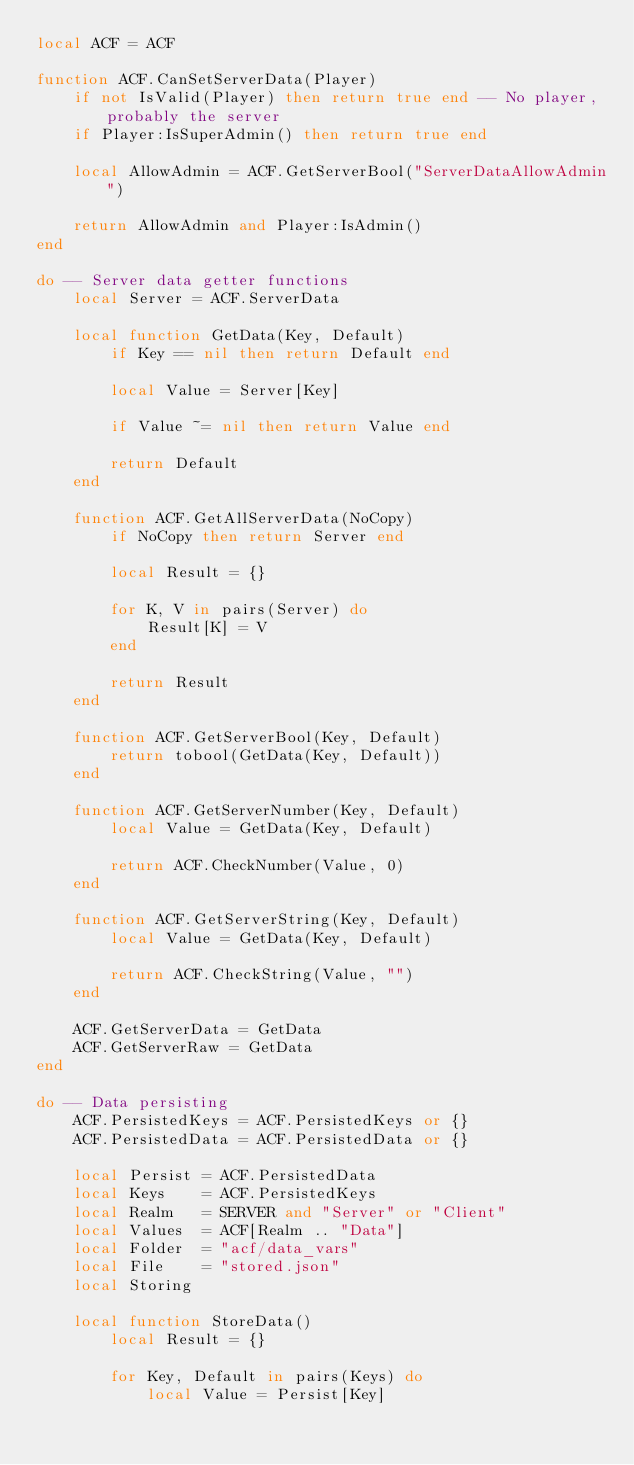Convert code to text. <code><loc_0><loc_0><loc_500><loc_500><_Lua_>local ACF = ACF

function ACF.CanSetServerData(Player)
	if not IsValid(Player) then return true end -- No player, probably the server
	if Player:IsSuperAdmin() then return true end

	local AllowAdmin = ACF.GetServerBool("ServerDataAllowAdmin")

	return AllowAdmin and Player:IsAdmin()
end

do -- Server data getter functions
	local Server = ACF.ServerData

	local function GetData(Key, Default)
		if Key == nil then return Default end

		local Value = Server[Key]

		if Value ~= nil then return Value end

		return Default
	end

	function ACF.GetAllServerData(NoCopy)
		if NoCopy then return Server end

		local Result = {}

		for K, V in pairs(Server) do
			Result[K] = V
		end

		return Result
	end

	function ACF.GetServerBool(Key, Default)
		return tobool(GetData(Key, Default))
	end

	function ACF.GetServerNumber(Key, Default)
		local Value = GetData(Key, Default)

		return ACF.CheckNumber(Value, 0)
	end

	function ACF.GetServerString(Key, Default)
		local Value = GetData(Key, Default)

		return ACF.CheckString(Value, "")
	end

	ACF.GetServerData = GetData
	ACF.GetServerRaw = GetData
end

do -- Data persisting
	ACF.PersistedKeys = ACF.PersistedKeys or {}
	ACF.PersistedData = ACF.PersistedData or {}

	local Persist = ACF.PersistedData
	local Keys    = ACF.PersistedKeys
	local Realm   = SERVER and "Server" or "Client"
	local Values  = ACF[Realm .. "Data"]
	local Folder  = "acf/data_vars"
	local File    = "stored.json"
	local Storing

	local function StoreData()
		local Result = {}

		for Key, Default in pairs(Keys) do
			local Value = Persist[Key]
</code> 